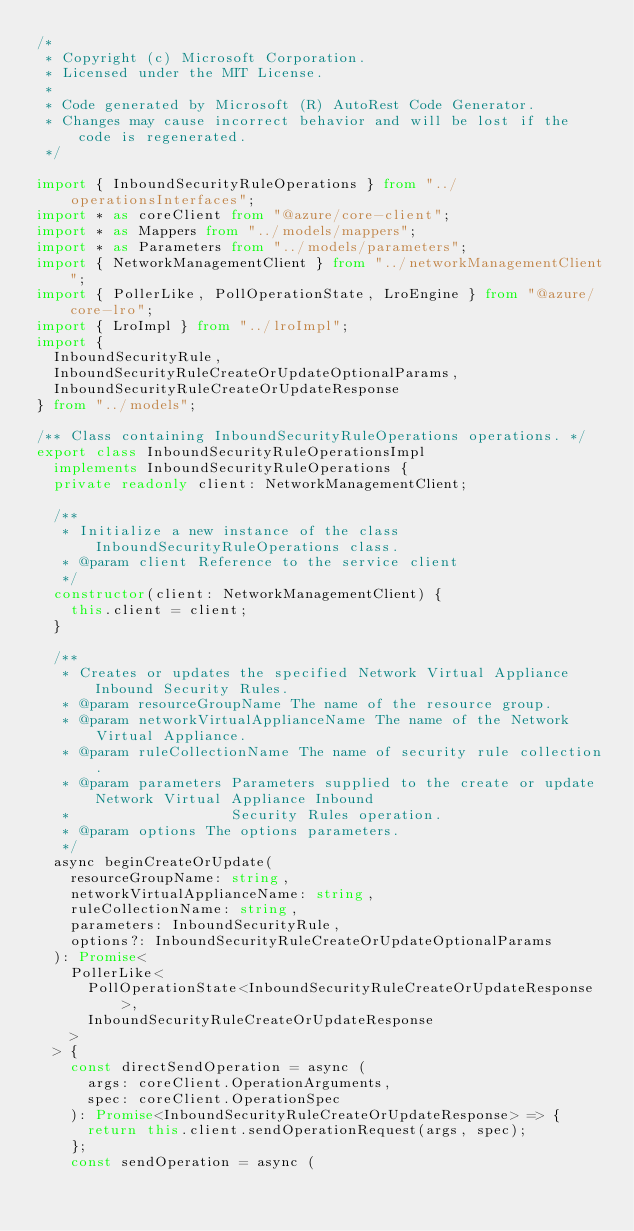<code> <loc_0><loc_0><loc_500><loc_500><_TypeScript_>/*
 * Copyright (c) Microsoft Corporation.
 * Licensed under the MIT License.
 *
 * Code generated by Microsoft (R) AutoRest Code Generator.
 * Changes may cause incorrect behavior and will be lost if the code is regenerated.
 */

import { InboundSecurityRuleOperations } from "../operationsInterfaces";
import * as coreClient from "@azure/core-client";
import * as Mappers from "../models/mappers";
import * as Parameters from "../models/parameters";
import { NetworkManagementClient } from "../networkManagementClient";
import { PollerLike, PollOperationState, LroEngine } from "@azure/core-lro";
import { LroImpl } from "../lroImpl";
import {
  InboundSecurityRule,
  InboundSecurityRuleCreateOrUpdateOptionalParams,
  InboundSecurityRuleCreateOrUpdateResponse
} from "../models";

/** Class containing InboundSecurityRuleOperations operations. */
export class InboundSecurityRuleOperationsImpl
  implements InboundSecurityRuleOperations {
  private readonly client: NetworkManagementClient;

  /**
   * Initialize a new instance of the class InboundSecurityRuleOperations class.
   * @param client Reference to the service client
   */
  constructor(client: NetworkManagementClient) {
    this.client = client;
  }

  /**
   * Creates or updates the specified Network Virtual Appliance Inbound Security Rules.
   * @param resourceGroupName The name of the resource group.
   * @param networkVirtualApplianceName The name of the Network Virtual Appliance.
   * @param ruleCollectionName The name of security rule collection.
   * @param parameters Parameters supplied to the create or update Network Virtual Appliance Inbound
   *                   Security Rules operation.
   * @param options The options parameters.
   */
  async beginCreateOrUpdate(
    resourceGroupName: string,
    networkVirtualApplianceName: string,
    ruleCollectionName: string,
    parameters: InboundSecurityRule,
    options?: InboundSecurityRuleCreateOrUpdateOptionalParams
  ): Promise<
    PollerLike<
      PollOperationState<InboundSecurityRuleCreateOrUpdateResponse>,
      InboundSecurityRuleCreateOrUpdateResponse
    >
  > {
    const directSendOperation = async (
      args: coreClient.OperationArguments,
      spec: coreClient.OperationSpec
    ): Promise<InboundSecurityRuleCreateOrUpdateResponse> => {
      return this.client.sendOperationRequest(args, spec);
    };
    const sendOperation = async (</code> 